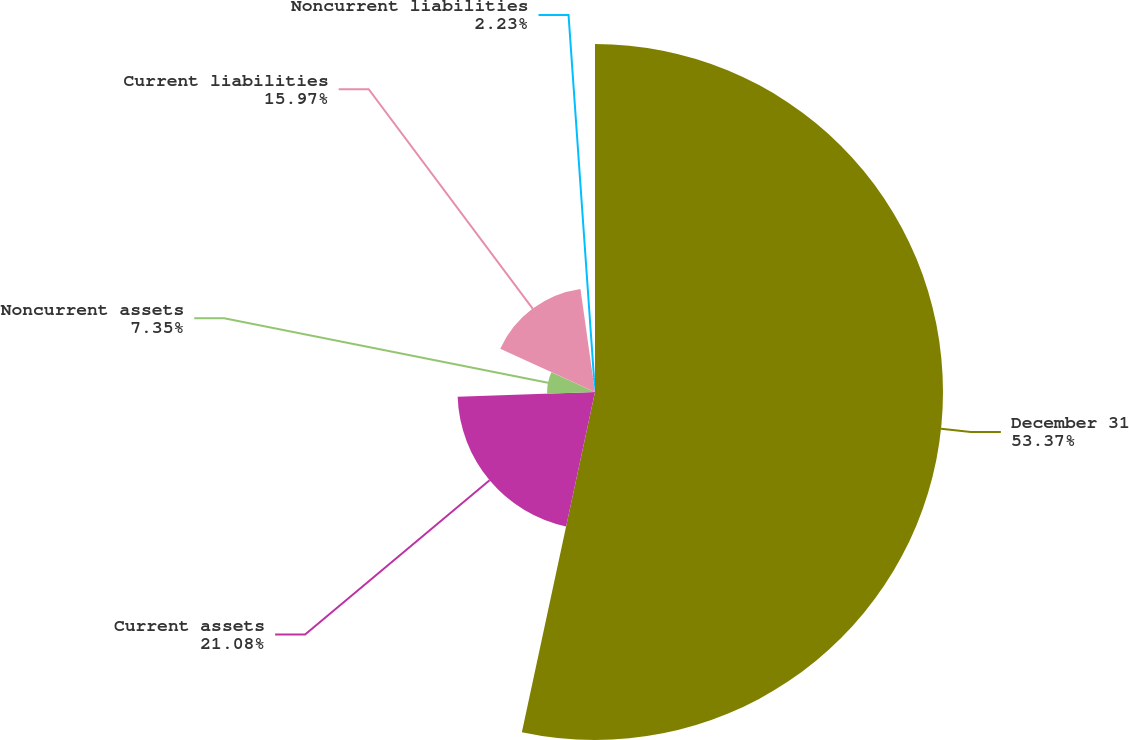Convert chart to OTSL. <chart><loc_0><loc_0><loc_500><loc_500><pie_chart><fcel>December 31<fcel>Current assets<fcel>Noncurrent assets<fcel>Current liabilities<fcel>Noncurrent liabilities<nl><fcel>53.37%<fcel>21.08%<fcel>7.35%<fcel>15.97%<fcel>2.23%<nl></chart> 